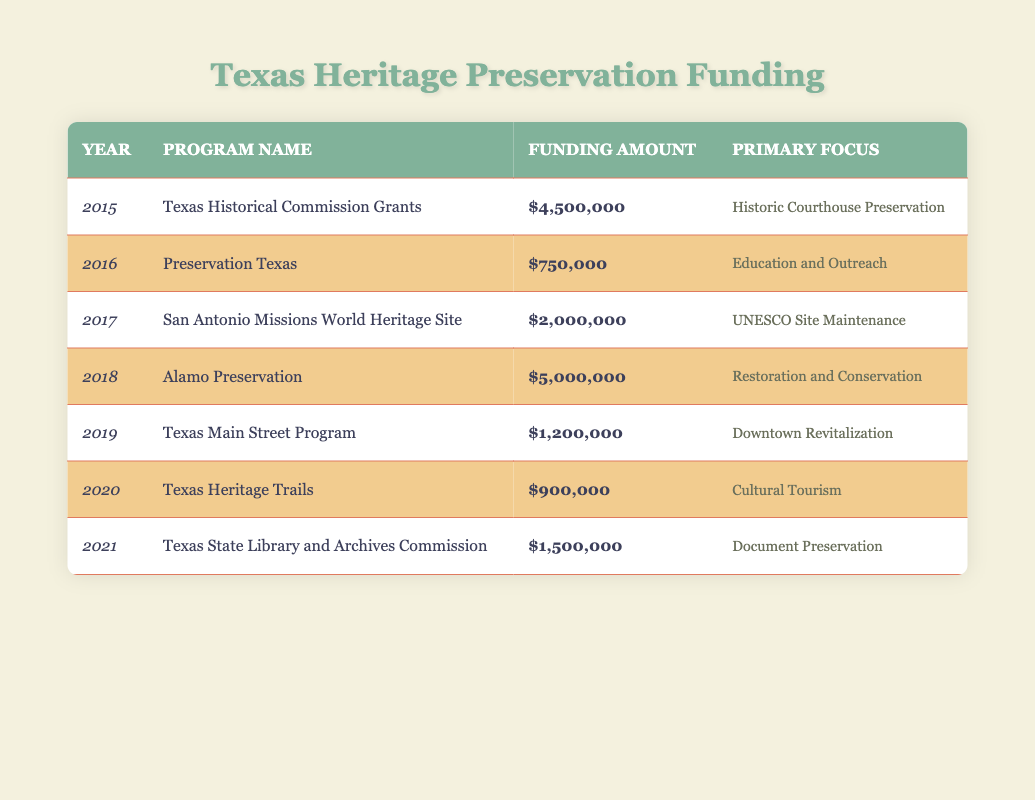What was the funding amount for the Texas Historical Commission Grants in 2015? The table shows that the funding amount for the Texas Historical Commission Grants in the year 2015 is $4,500,000.
Answer: $4,500,000 Which program had the highest funding amount, and what was that amount? By reviewing the funding amounts in each row of the table, the Alamo Preservation program in 2018 had the highest funding amount of $5,000,000.
Answer: Alamo Preservation, $5,000,000 How much total funding was allocated for all programs from 2015 to 2021? To find the total funding, I summed the funding amounts for each year: $4,500,000 + $750,000 + $2,000,000 + $5,000,000 + $1,200,000 + $900,000 + $1,500,000 = $15,850,000.
Answer: $15,850,000 Was there any funding allocated for cultural tourism in the years provided? Yes, the Texas Heritage Trails program in 2020 received funding aimed at cultural tourism, with an amount of $900,000.
Answer: Yes In which years was funding allocated for education and outreach, and how much was it? The table indicates that in 2016, the Preservation Texas program focused on education and outreach, with a funding amount of $750,000.
Answer: 2016, $750,000 What is the difference in funding amount between the highest and lowest funded programs? The highest funding was for the Alamo Preservation at $5,000,000, and the lowest was for the Preservation Texas program at $750,000. The difference is $5,000,000 - $750,000 = $4,250,000.
Answer: $4,250,000 Was the San Antonio Missions World Heritage Site program's funding more or less than $3,000,000? The funding for the San Antonio Missions World Heritage Site program in 2017 was $2,000,000, which is less than $3,000,000.
Answer: Less Identify the primary focus of the program with the lowest funding The program with the lowest funding is the Preservation Texas program from 2016, which has the primary focus on Education and Outreach.
Answer: Education and Outreach 